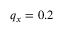<formula> <loc_0><loc_0><loc_500><loc_500>q _ { x } = 0 . 2</formula> 